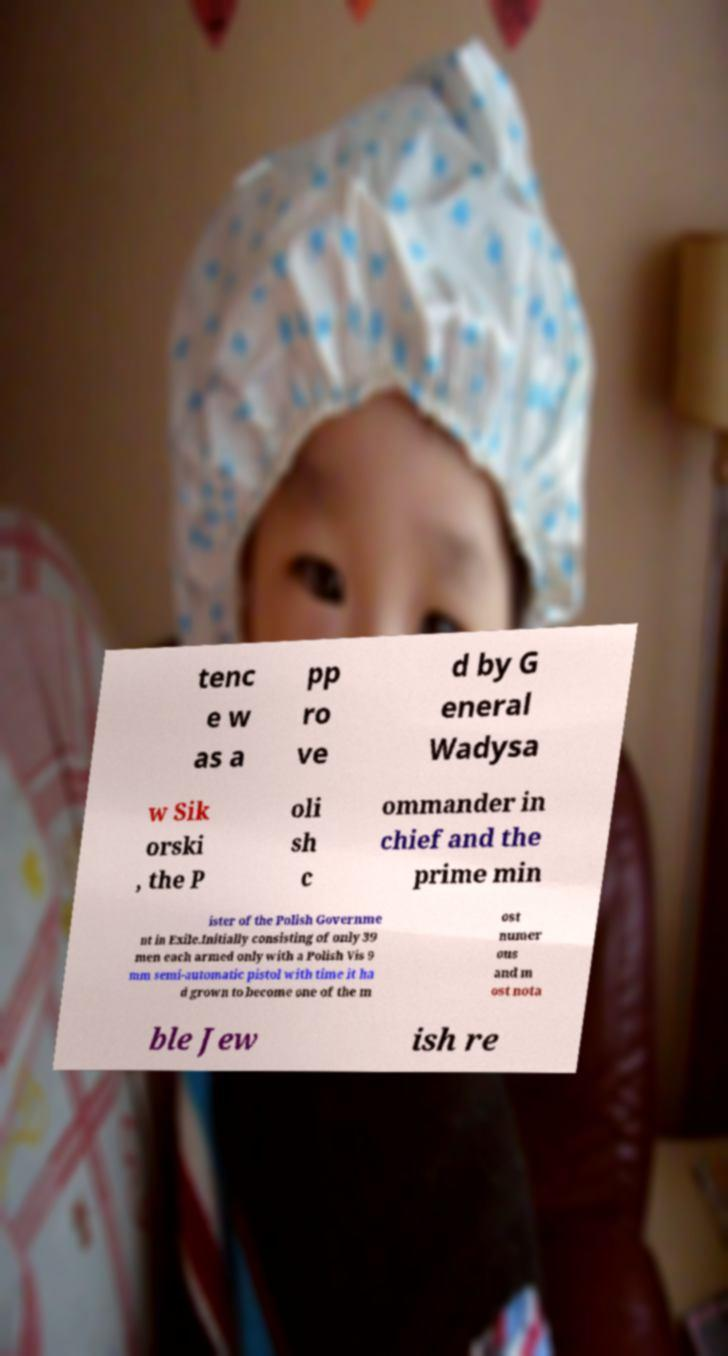Could you assist in decoding the text presented in this image and type it out clearly? tenc e w as a pp ro ve d by G eneral Wadysa w Sik orski , the P oli sh c ommander in chief and the prime min ister of the Polish Governme nt in Exile.Initially consisting of only 39 men each armed only with a Polish Vis 9 mm semi-automatic pistol with time it ha d grown to become one of the m ost numer ous and m ost nota ble Jew ish re 